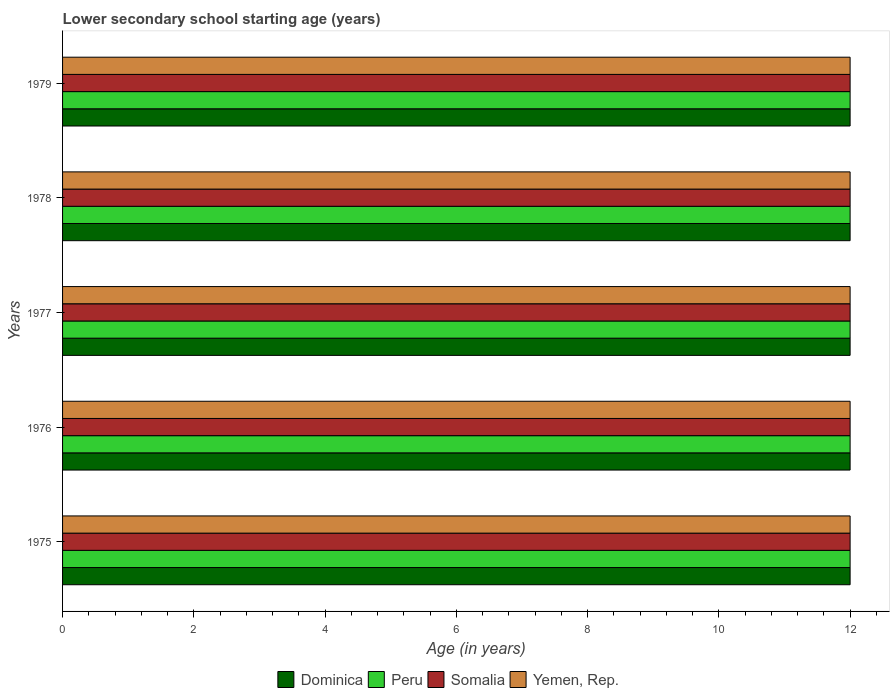Are the number of bars per tick equal to the number of legend labels?
Give a very brief answer. Yes. How many bars are there on the 1st tick from the top?
Offer a terse response. 4. How many bars are there on the 4th tick from the bottom?
Provide a short and direct response. 4. What is the label of the 4th group of bars from the top?
Ensure brevity in your answer.  1976. Across all years, what is the minimum lower secondary school starting age of children in Dominica?
Your answer should be very brief. 12. In which year was the lower secondary school starting age of children in Peru maximum?
Your response must be concise. 1975. In which year was the lower secondary school starting age of children in Yemen, Rep. minimum?
Make the answer very short. 1975. What is the difference between the lower secondary school starting age of children in Peru in 1976 and that in 1978?
Provide a succinct answer. 0. In the year 1978, what is the difference between the lower secondary school starting age of children in Peru and lower secondary school starting age of children in Yemen, Rep.?
Provide a succinct answer. 0. What is the difference between the highest and the second highest lower secondary school starting age of children in Dominica?
Make the answer very short. 0. What is the difference between the highest and the lowest lower secondary school starting age of children in Dominica?
Offer a very short reply. 0. What does the 2nd bar from the top in 1977 represents?
Offer a very short reply. Somalia. What does the 1st bar from the bottom in 1977 represents?
Your answer should be compact. Dominica. How many bars are there?
Provide a succinct answer. 20. Are all the bars in the graph horizontal?
Offer a terse response. Yes. How many years are there in the graph?
Ensure brevity in your answer.  5. What is the difference between two consecutive major ticks on the X-axis?
Offer a terse response. 2. Does the graph contain any zero values?
Ensure brevity in your answer.  No. What is the title of the graph?
Provide a succinct answer. Lower secondary school starting age (years). Does "Tunisia" appear as one of the legend labels in the graph?
Give a very brief answer. No. What is the label or title of the X-axis?
Your answer should be compact. Age (in years). What is the label or title of the Y-axis?
Keep it short and to the point. Years. What is the Age (in years) of Dominica in 1975?
Your response must be concise. 12. What is the Age (in years) in Peru in 1975?
Give a very brief answer. 12. What is the Age (in years) of Somalia in 1975?
Provide a succinct answer. 12. What is the Age (in years) of Yemen, Rep. in 1975?
Give a very brief answer. 12. What is the Age (in years) of Peru in 1976?
Provide a short and direct response. 12. What is the Age (in years) of Somalia in 1976?
Give a very brief answer. 12. What is the Age (in years) in Yemen, Rep. in 1976?
Your answer should be very brief. 12. What is the Age (in years) in Dominica in 1977?
Your answer should be very brief. 12. What is the Age (in years) in Peru in 1977?
Give a very brief answer. 12. What is the Age (in years) of Somalia in 1977?
Keep it short and to the point. 12. What is the Age (in years) of Dominica in 1978?
Offer a terse response. 12. What is the Age (in years) of Peru in 1979?
Your answer should be compact. 12. What is the Age (in years) in Somalia in 1979?
Your answer should be very brief. 12. What is the Age (in years) of Yemen, Rep. in 1979?
Offer a terse response. 12. Across all years, what is the minimum Age (in years) in Somalia?
Give a very brief answer. 12. What is the total Age (in years) in Peru in the graph?
Your response must be concise. 60. What is the difference between the Age (in years) of Somalia in 1975 and that in 1976?
Your response must be concise. 0. What is the difference between the Age (in years) of Dominica in 1975 and that in 1977?
Provide a short and direct response. 0. What is the difference between the Age (in years) in Peru in 1975 and that in 1977?
Your answer should be compact. 0. What is the difference between the Age (in years) of Dominica in 1975 and that in 1978?
Your answer should be very brief. 0. What is the difference between the Age (in years) of Somalia in 1975 and that in 1978?
Provide a short and direct response. 0. What is the difference between the Age (in years) of Somalia in 1975 and that in 1979?
Keep it short and to the point. 0. What is the difference between the Age (in years) in Dominica in 1976 and that in 1977?
Make the answer very short. 0. What is the difference between the Age (in years) in Yemen, Rep. in 1976 and that in 1977?
Offer a terse response. 0. What is the difference between the Age (in years) of Peru in 1976 and that in 1979?
Make the answer very short. 0. What is the difference between the Age (in years) in Somalia in 1976 and that in 1979?
Ensure brevity in your answer.  0. What is the difference between the Age (in years) in Yemen, Rep. in 1976 and that in 1979?
Offer a very short reply. 0. What is the difference between the Age (in years) in Dominica in 1977 and that in 1978?
Provide a succinct answer. 0. What is the difference between the Age (in years) in Somalia in 1977 and that in 1978?
Give a very brief answer. 0. What is the difference between the Age (in years) of Dominica in 1977 and that in 1979?
Offer a terse response. 0. What is the difference between the Age (in years) of Somalia in 1977 and that in 1979?
Provide a succinct answer. 0. What is the difference between the Age (in years) of Yemen, Rep. in 1977 and that in 1979?
Provide a succinct answer. 0. What is the difference between the Age (in years) in Somalia in 1978 and that in 1979?
Give a very brief answer. 0. What is the difference between the Age (in years) of Dominica in 1975 and the Age (in years) of Somalia in 1976?
Ensure brevity in your answer.  0. What is the difference between the Age (in years) in Peru in 1975 and the Age (in years) in Somalia in 1976?
Ensure brevity in your answer.  0. What is the difference between the Age (in years) of Somalia in 1975 and the Age (in years) of Yemen, Rep. in 1976?
Make the answer very short. 0. What is the difference between the Age (in years) in Dominica in 1975 and the Age (in years) in Peru in 1977?
Give a very brief answer. 0. What is the difference between the Age (in years) in Dominica in 1975 and the Age (in years) in Somalia in 1977?
Your answer should be compact. 0. What is the difference between the Age (in years) of Somalia in 1975 and the Age (in years) of Yemen, Rep. in 1977?
Keep it short and to the point. 0. What is the difference between the Age (in years) of Dominica in 1975 and the Age (in years) of Peru in 1978?
Provide a short and direct response. 0. What is the difference between the Age (in years) in Dominica in 1975 and the Age (in years) in Somalia in 1978?
Give a very brief answer. 0. What is the difference between the Age (in years) of Peru in 1975 and the Age (in years) of Somalia in 1978?
Offer a terse response. 0. What is the difference between the Age (in years) of Dominica in 1975 and the Age (in years) of Somalia in 1979?
Offer a terse response. 0. What is the difference between the Age (in years) in Dominica in 1975 and the Age (in years) in Yemen, Rep. in 1979?
Your response must be concise. 0. What is the difference between the Age (in years) of Peru in 1975 and the Age (in years) of Yemen, Rep. in 1979?
Make the answer very short. 0. What is the difference between the Age (in years) of Dominica in 1976 and the Age (in years) of Peru in 1977?
Your answer should be compact. 0. What is the difference between the Age (in years) in Dominica in 1976 and the Age (in years) in Yemen, Rep. in 1977?
Provide a succinct answer. 0. What is the difference between the Age (in years) in Peru in 1976 and the Age (in years) in Somalia in 1977?
Your answer should be compact. 0. What is the difference between the Age (in years) in Dominica in 1976 and the Age (in years) in Peru in 1978?
Your response must be concise. 0. What is the difference between the Age (in years) of Peru in 1976 and the Age (in years) of Somalia in 1978?
Offer a terse response. 0. What is the difference between the Age (in years) of Somalia in 1976 and the Age (in years) of Yemen, Rep. in 1978?
Your response must be concise. 0. What is the difference between the Age (in years) of Dominica in 1976 and the Age (in years) of Peru in 1979?
Provide a succinct answer. 0. What is the difference between the Age (in years) in Peru in 1976 and the Age (in years) in Somalia in 1979?
Ensure brevity in your answer.  0. What is the difference between the Age (in years) of Peru in 1976 and the Age (in years) of Yemen, Rep. in 1979?
Provide a short and direct response. 0. What is the difference between the Age (in years) in Somalia in 1976 and the Age (in years) in Yemen, Rep. in 1979?
Your answer should be compact. 0. What is the difference between the Age (in years) of Dominica in 1977 and the Age (in years) of Peru in 1978?
Keep it short and to the point. 0. What is the difference between the Age (in years) of Dominica in 1977 and the Age (in years) of Yemen, Rep. in 1978?
Keep it short and to the point. 0. What is the difference between the Age (in years) of Peru in 1977 and the Age (in years) of Somalia in 1978?
Make the answer very short. 0. What is the difference between the Age (in years) of Dominica in 1977 and the Age (in years) of Yemen, Rep. in 1979?
Make the answer very short. 0. What is the difference between the Age (in years) in Dominica in 1978 and the Age (in years) in Somalia in 1979?
Your response must be concise. 0. What is the difference between the Age (in years) of Dominica in 1978 and the Age (in years) of Yemen, Rep. in 1979?
Ensure brevity in your answer.  0. What is the difference between the Age (in years) in Peru in 1978 and the Age (in years) in Somalia in 1979?
Give a very brief answer. 0. What is the difference between the Age (in years) of Peru in 1978 and the Age (in years) of Yemen, Rep. in 1979?
Provide a short and direct response. 0. What is the average Age (in years) of Peru per year?
Offer a terse response. 12. In the year 1975, what is the difference between the Age (in years) in Dominica and Age (in years) in Somalia?
Offer a very short reply. 0. In the year 1975, what is the difference between the Age (in years) in Dominica and Age (in years) in Yemen, Rep.?
Provide a succinct answer. 0. In the year 1975, what is the difference between the Age (in years) in Peru and Age (in years) in Yemen, Rep.?
Your response must be concise. 0. In the year 1975, what is the difference between the Age (in years) of Somalia and Age (in years) of Yemen, Rep.?
Your response must be concise. 0. In the year 1976, what is the difference between the Age (in years) of Dominica and Age (in years) of Yemen, Rep.?
Ensure brevity in your answer.  0. In the year 1976, what is the difference between the Age (in years) of Peru and Age (in years) of Somalia?
Offer a terse response. 0. In the year 1976, what is the difference between the Age (in years) of Peru and Age (in years) of Yemen, Rep.?
Offer a terse response. 0. In the year 1977, what is the difference between the Age (in years) of Dominica and Age (in years) of Peru?
Your response must be concise. 0. In the year 1977, what is the difference between the Age (in years) in Peru and Age (in years) in Yemen, Rep.?
Your answer should be compact. 0. In the year 1978, what is the difference between the Age (in years) in Dominica and Age (in years) in Yemen, Rep.?
Your answer should be compact. 0. In the year 1978, what is the difference between the Age (in years) of Peru and Age (in years) of Somalia?
Offer a terse response. 0. In the year 1978, what is the difference between the Age (in years) in Peru and Age (in years) in Yemen, Rep.?
Your answer should be compact. 0. In the year 1978, what is the difference between the Age (in years) in Somalia and Age (in years) in Yemen, Rep.?
Offer a terse response. 0. In the year 1979, what is the difference between the Age (in years) of Dominica and Age (in years) of Peru?
Your answer should be very brief. 0. In the year 1979, what is the difference between the Age (in years) in Dominica and Age (in years) in Somalia?
Provide a short and direct response. 0. In the year 1979, what is the difference between the Age (in years) in Dominica and Age (in years) in Yemen, Rep.?
Make the answer very short. 0. What is the ratio of the Age (in years) of Somalia in 1975 to that in 1976?
Your response must be concise. 1. What is the ratio of the Age (in years) in Yemen, Rep. in 1975 to that in 1976?
Provide a succinct answer. 1. What is the ratio of the Age (in years) of Dominica in 1975 to that in 1977?
Your response must be concise. 1. What is the ratio of the Age (in years) of Peru in 1975 to that in 1977?
Ensure brevity in your answer.  1. What is the ratio of the Age (in years) of Somalia in 1975 to that in 1977?
Your answer should be compact. 1. What is the ratio of the Age (in years) in Yemen, Rep. in 1975 to that in 1977?
Make the answer very short. 1. What is the ratio of the Age (in years) in Somalia in 1975 to that in 1978?
Your response must be concise. 1. What is the ratio of the Age (in years) of Peru in 1975 to that in 1979?
Keep it short and to the point. 1. What is the ratio of the Age (in years) of Yemen, Rep. in 1975 to that in 1979?
Keep it short and to the point. 1. What is the ratio of the Age (in years) in Dominica in 1976 to that in 1977?
Offer a very short reply. 1. What is the ratio of the Age (in years) of Peru in 1976 to that in 1977?
Give a very brief answer. 1. What is the ratio of the Age (in years) of Peru in 1976 to that in 1978?
Your answer should be very brief. 1. What is the ratio of the Age (in years) of Peru in 1976 to that in 1979?
Offer a terse response. 1. What is the ratio of the Age (in years) in Somalia in 1976 to that in 1979?
Give a very brief answer. 1. What is the ratio of the Age (in years) of Peru in 1977 to that in 1978?
Give a very brief answer. 1. What is the ratio of the Age (in years) of Yemen, Rep. in 1977 to that in 1978?
Your response must be concise. 1. What is the ratio of the Age (in years) of Peru in 1977 to that in 1979?
Give a very brief answer. 1. What is the ratio of the Age (in years) in Somalia in 1977 to that in 1979?
Your answer should be very brief. 1. What is the ratio of the Age (in years) of Yemen, Rep. in 1977 to that in 1979?
Your response must be concise. 1. What is the ratio of the Age (in years) in Somalia in 1978 to that in 1979?
Make the answer very short. 1. What is the difference between the highest and the second highest Age (in years) in Somalia?
Your answer should be compact. 0. What is the difference between the highest and the second highest Age (in years) of Yemen, Rep.?
Give a very brief answer. 0. What is the difference between the highest and the lowest Age (in years) of Dominica?
Your answer should be very brief. 0. What is the difference between the highest and the lowest Age (in years) of Peru?
Ensure brevity in your answer.  0. What is the difference between the highest and the lowest Age (in years) in Somalia?
Give a very brief answer. 0. What is the difference between the highest and the lowest Age (in years) in Yemen, Rep.?
Your answer should be compact. 0. 